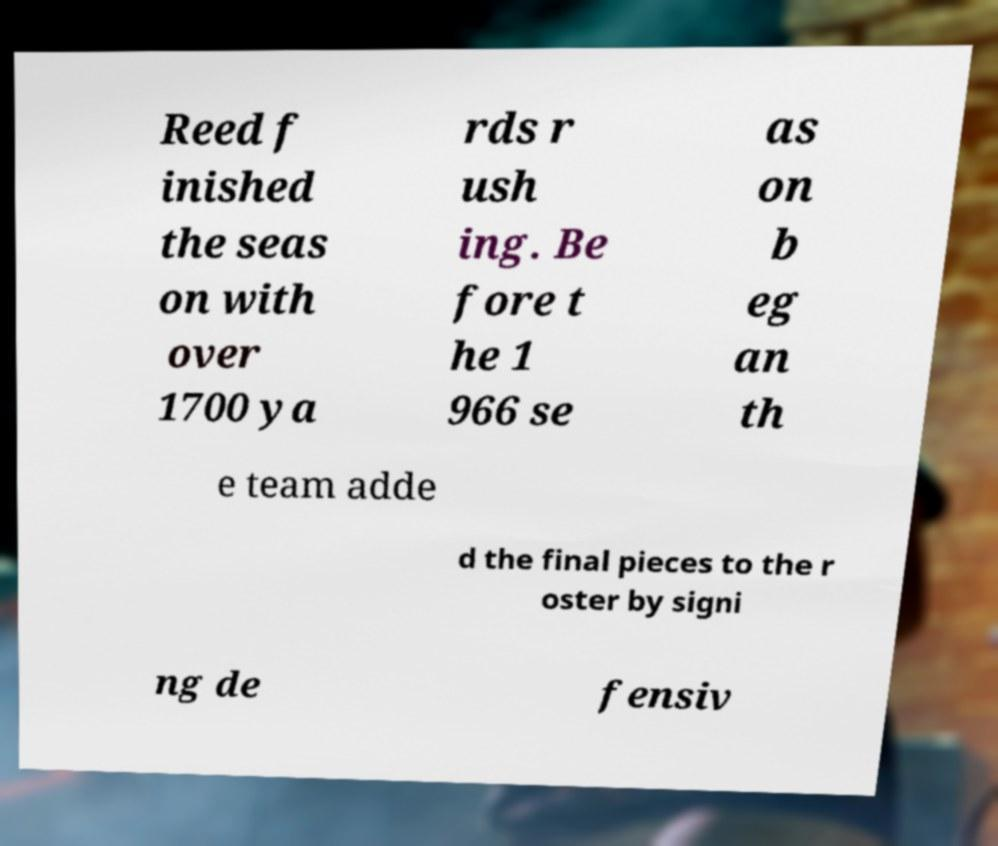Please read and relay the text visible in this image. What does it say? Reed f inished the seas on with over 1700 ya rds r ush ing. Be fore t he 1 966 se as on b eg an th e team adde d the final pieces to the r oster by signi ng de fensiv 